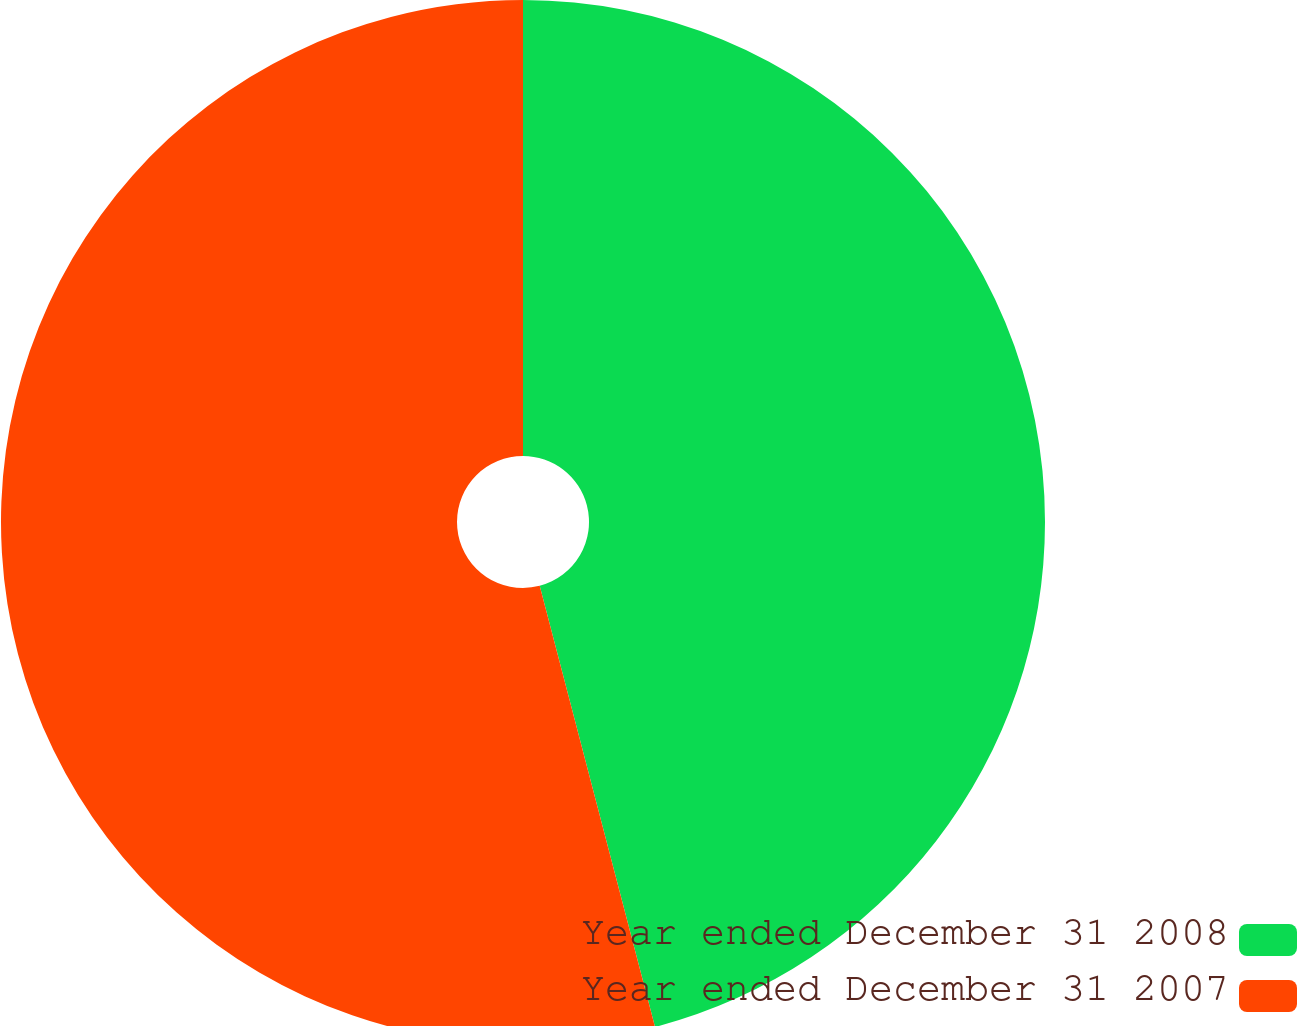Convert chart to OTSL. <chart><loc_0><loc_0><loc_500><loc_500><pie_chart><fcel>Year ended December 31 2008<fcel>Year ended December 31 2007<nl><fcel>45.93%<fcel>54.07%<nl></chart> 